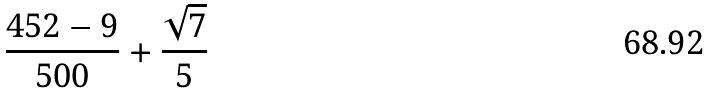Convert formula to latex. <formula><loc_0><loc_0><loc_500><loc_500>\frac { 4 5 2 - 9 } { 5 0 0 } + \frac { \sqrt { 7 } } { 5 }</formula> 